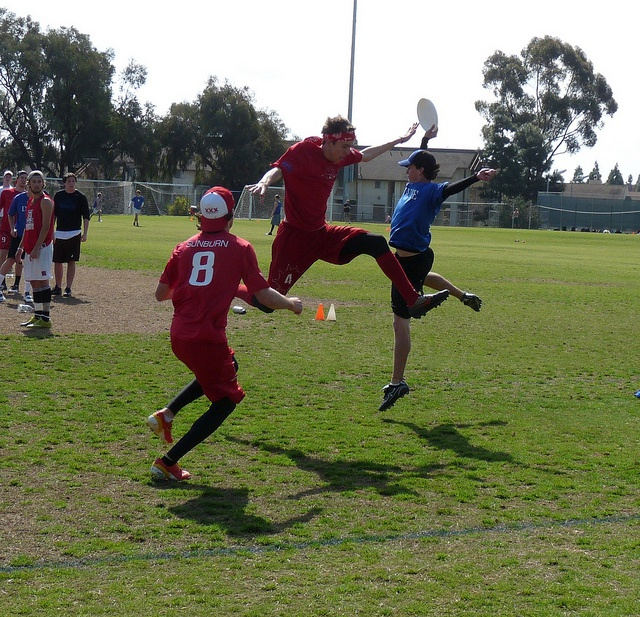Describe the objects in this image and their specific colors. I can see people in white, maroon, black, darkgreen, and gray tones, people in white, black, maroon, gray, and olive tones, people in white, black, gray, navy, and olive tones, people in white, maroon, black, and gray tones, and people in white, black, maroon, and gray tones in this image. 